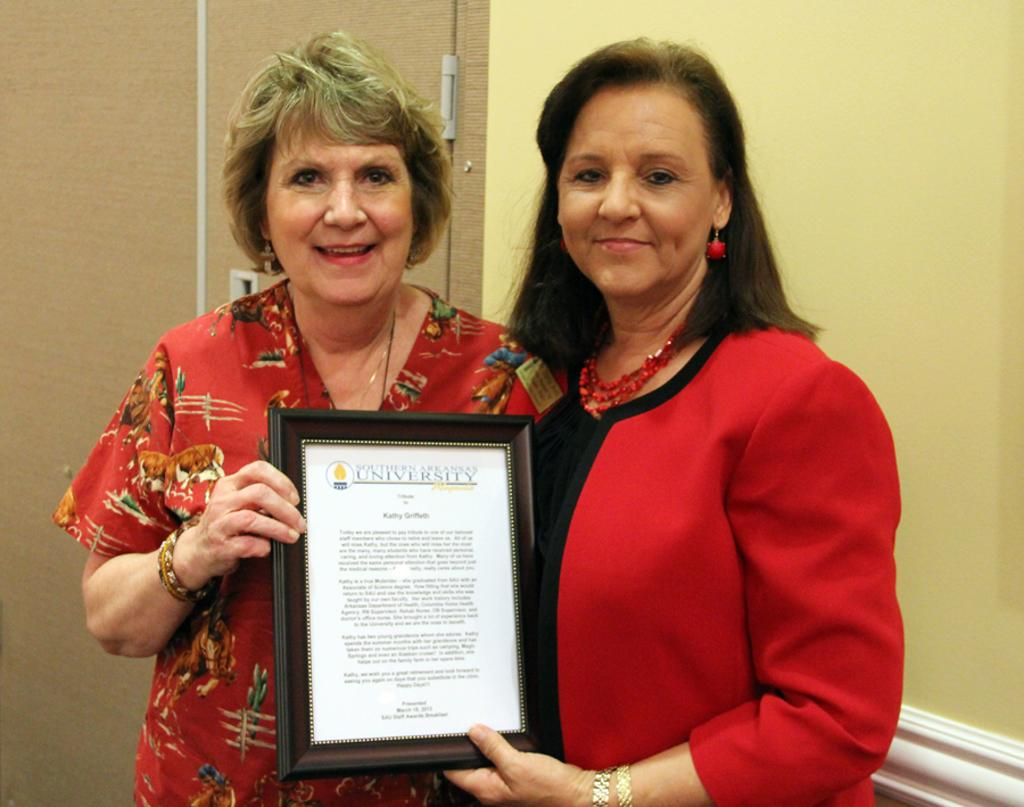How many people are in the image? There are two persons in the image. What are the two persons holding? The two persons are holding a certificate. What type of tail can be seen on the certificate in the image? There is no tail present on the certificate in the image. What crime are the two persons being accused of in the image? There is no indication of any crime in the image; the two persons are holding a certificate. 